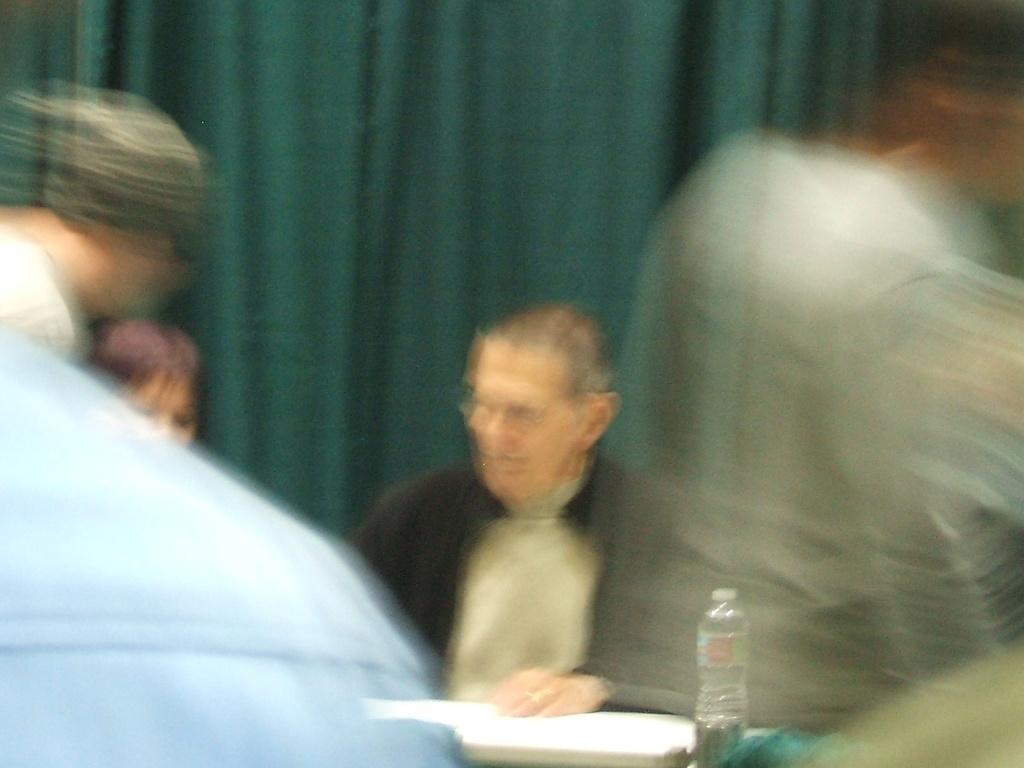Can you describe this image briefly? This is a blur image. Here we can see few persons and in the middle there is a man sitting at the table and there is a water bottle on it. 